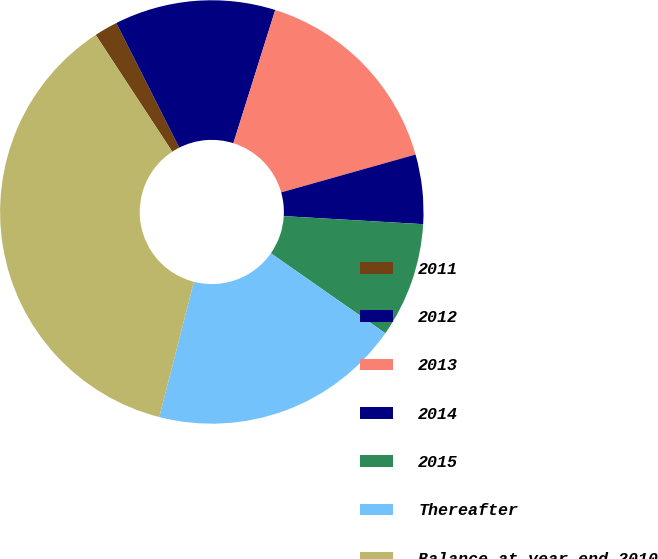Convert chart. <chart><loc_0><loc_0><loc_500><loc_500><pie_chart><fcel>2011<fcel>2012<fcel>2013<fcel>2014<fcel>2015<fcel>Thereafter<fcel>Balance at year-end 2010<nl><fcel>1.79%<fcel>12.29%<fcel>15.78%<fcel>5.29%<fcel>8.79%<fcel>19.28%<fcel>36.77%<nl></chart> 